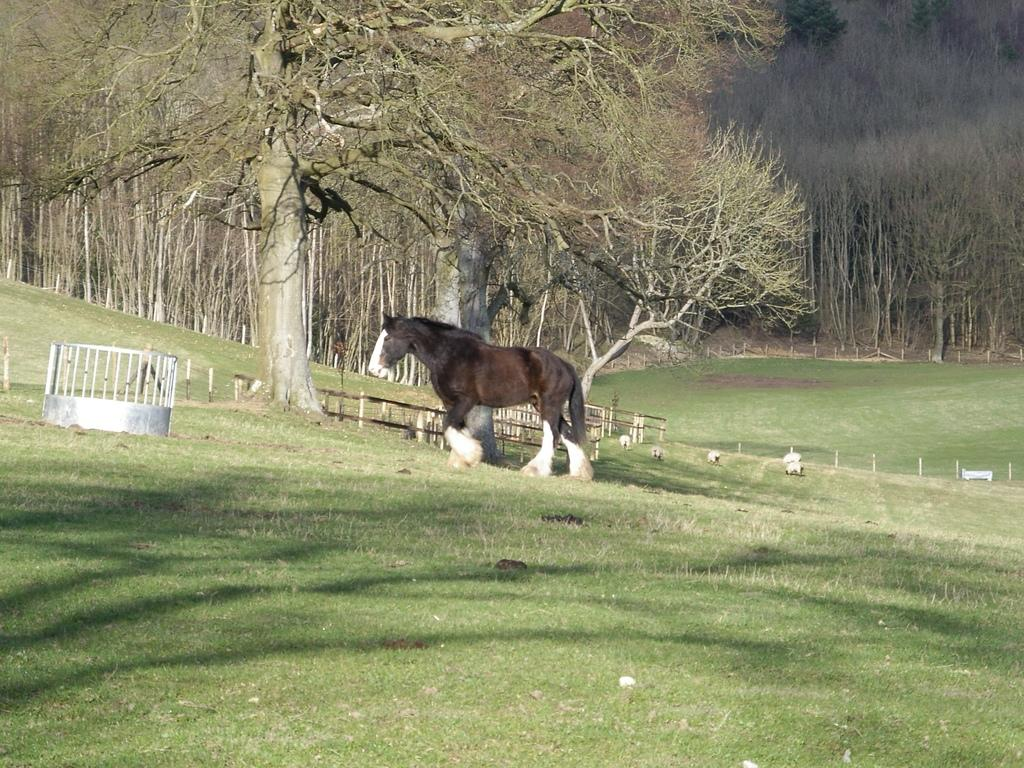What type of vegetation can be seen in the image? There are trees in the image. What animal is located in the middle of the image? There is a horse in the middle of the image. What is the ground covered with in the image? There is grass on the ground in the image. What type of door can be seen in the image? There is no door present in the image; it features trees, a horse, and grass. What type of sticks are being used by the horse in the image? There are no sticks present in the image, and the horse is not using any. 